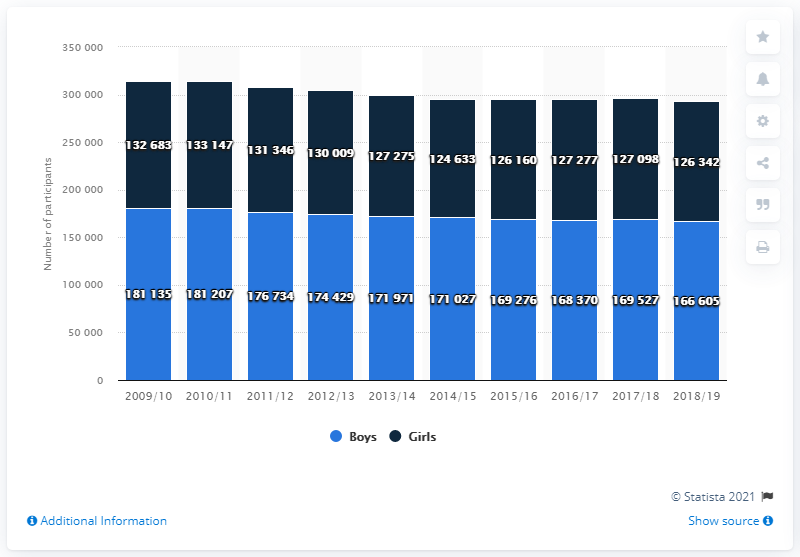What is the sum of the highest value and lowest value of light blue bar? The sum of the highest and lowest values for the light blue bars, which represent the number of male participations, is 347,740. Specifically, the highest number is from the year 2011/12 with 183,207 participants, and the lowest from the year 2016/17 with 164,533 participants. 